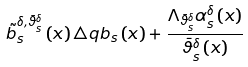Convert formula to latex. <formula><loc_0><loc_0><loc_500><loc_500>\tilde { b } _ { s } ^ { \delta , \bar { \vartheta } _ { s } ^ { \delta } } \left ( x \right ) \triangle q b _ { s } \left ( x \right ) + \frac { \Lambda _ { \bar { \vartheta } _ { s } ^ { \delta } } \alpha _ { s } ^ { \delta } \left ( x \right ) } { \bar { \vartheta } _ { s } ^ { \delta } \left ( x \right ) }</formula> 